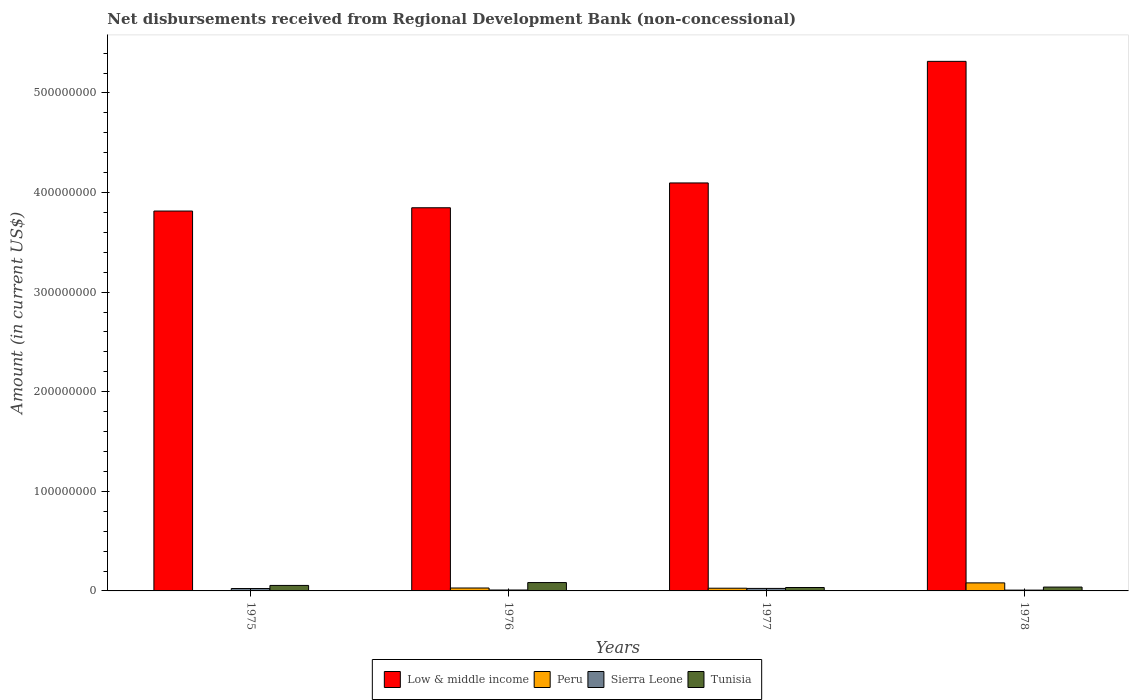How many different coloured bars are there?
Provide a succinct answer. 4. How many groups of bars are there?
Provide a succinct answer. 4. How many bars are there on the 2nd tick from the left?
Provide a short and direct response. 4. What is the label of the 1st group of bars from the left?
Provide a short and direct response. 1975. What is the amount of disbursements received from Regional Development Bank in Tunisia in 1975?
Your answer should be compact. 5.51e+06. Across all years, what is the maximum amount of disbursements received from Regional Development Bank in Peru?
Your response must be concise. 8.07e+06. Across all years, what is the minimum amount of disbursements received from Regional Development Bank in Low & middle income?
Your answer should be compact. 3.81e+08. In which year was the amount of disbursements received from Regional Development Bank in Peru maximum?
Ensure brevity in your answer.  1978. What is the total amount of disbursements received from Regional Development Bank in Low & middle income in the graph?
Keep it short and to the point. 1.71e+09. What is the difference between the amount of disbursements received from Regional Development Bank in Peru in 1976 and that in 1977?
Your answer should be very brief. 2.03e+05. What is the difference between the amount of disbursements received from Regional Development Bank in Low & middle income in 1977 and the amount of disbursements received from Regional Development Bank in Sierra Leone in 1978?
Offer a very short reply. 4.09e+08. What is the average amount of disbursements received from Regional Development Bank in Low & middle income per year?
Offer a very short reply. 4.27e+08. In the year 1976, what is the difference between the amount of disbursements received from Regional Development Bank in Sierra Leone and amount of disbursements received from Regional Development Bank in Peru?
Give a very brief answer. -2.01e+06. What is the ratio of the amount of disbursements received from Regional Development Bank in Sierra Leone in 1975 to that in 1976?
Offer a terse response. 2.64. Is the amount of disbursements received from Regional Development Bank in Low & middle income in 1977 less than that in 1978?
Ensure brevity in your answer.  Yes. What is the difference between the highest and the second highest amount of disbursements received from Regional Development Bank in Tunisia?
Keep it short and to the point. 2.87e+06. What is the difference between the highest and the lowest amount of disbursements received from Regional Development Bank in Tunisia?
Your answer should be very brief. 4.94e+06. Is the sum of the amount of disbursements received from Regional Development Bank in Low & middle income in 1976 and 1978 greater than the maximum amount of disbursements received from Regional Development Bank in Sierra Leone across all years?
Keep it short and to the point. Yes. How many years are there in the graph?
Your answer should be compact. 4. How many legend labels are there?
Make the answer very short. 4. How are the legend labels stacked?
Provide a succinct answer. Horizontal. What is the title of the graph?
Provide a short and direct response. Net disbursements received from Regional Development Bank (non-concessional). Does "India" appear as one of the legend labels in the graph?
Offer a terse response. No. What is the label or title of the Y-axis?
Give a very brief answer. Amount (in current US$). What is the Amount (in current US$) in Low & middle income in 1975?
Provide a succinct answer. 3.81e+08. What is the Amount (in current US$) of Peru in 1975?
Offer a terse response. 0. What is the Amount (in current US$) in Sierra Leone in 1975?
Ensure brevity in your answer.  2.41e+06. What is the Amount (in current US$) of Tunisia in 1975?
Provide a succinct answer. 5.51e+06. What is the Amount (in current US$) in Low & middle income in 1976?
Ensure brevity in your answer.  3.85e+08. What is the Amount (in current US$) of Peru in 1976?
Your response must be concise. 2.93e+06. What is the Amount (in current US$) in Sierra Leone in 1976?
Give a very brief answer. 9.14e+05. What is the Amount (in current US$) in Tunisia in 1976?
Provide a short and direct response. 8.38e+06. What is the Amount (in current US$) in Low & middle income in 1977?
Give a very brief answer. 4.10e+08. What is the Amount (in current US$) of Peru in 1977?
Your response must be concise. 2.72e+06. What is the Amount (in current US$) of Sierra Leone in 1977?
Your response must be concise. 2.51e+06. What is the Amount (in current US$) in Tunisia in 1977?
Provide a short and direct response. 3.44e+06. What is the Amount (in current US$) of Low & middle income in 1978?
Provide a succinct answer. 5.32e+08. What is the Amount (in current US$) in Peru in 1978?
Your answer should be very brief. 8.07e+06. What is the Amount (in current US$) of Sierra Leone in 1978?
Keep it short and to the point. 8.01e+05. What is the Amount (in current US$) in Tunisia in 1978?
Your answer should be very brief. 3.87e+06. Across all years, what is the maximum Amount (in current US$) of Low & middle income?
Make the answer very short. 5.32e+08. Across all years, what is the maximum Amount (in current US$) in Peru?
Offer a very short reply. 8.07e+06. Across all years, what is the maximum Amount (in current US$) in Sierra Leone?
Offer a terse response. 2.51e+06. Across all years, what is the maximum Amount (in current US$) in Tunisia?
Offer a very short reply. 8.38e+06. Across all years, what is the minimum Amount (in current US$) in Low & middle income?
Provide a succinct answer. 3.81e+08. Across all years, what is the minimum Amount (in current US$) in Sierra Leone?
Keep it short and to the point. 8.01e+05. Across all years, what is the minimum Amount (in current US$) in Tunisia?
Offer a very short reply. 3.44e+06. What is the total Amount (in current US$) of Low & middle income in the graph?
Your answer should be very brief. 1.71e+09. What is the total Amount (in current US$) of Peru in the graph?
Keep it short and to the point. 1.37e+07. What is the total Amount (in current US$) of Sierra Leone in the graph?
Your answer should be compact. 6.64e+06. What is the total Amount (in current US$) in Tunisia in the graph?
Keep it short and to the point. 2.12e+07. What is the difference between the Amount (in current US$) in Low & middle income in 1975 and that in 1976?
Offer a terse response. -3.29e+06. What is the difference between the Amount (in current US$) of Sierra Leone in 1975 and that in 1976?
Ensure brevity in your answer.  1.50e+06. What is the difference between the Amount (in current US$) in Tunisia in 1975 and that in 1976?
Offer a terse response. -2.87e+06. What is the difference between the Amount (in current US$) of Low & middle income in 1975 and that in 1977?
Give a very brief answer. -2.82e+07. What is the difference between the Amount (in current US$) of Sierra Leone in 1975 and that in 1977?
Provide a short and direct response. -9.70e+04. What is the difference between the Amount (in current US$) of Tunisia in 1975 and that in 1977?
Provide a short and direct response. 2.07e+06. What is the difference between the Amount (in current US$) of Low & middle income in 1975 and that in 1978?
Provide a short and direct response. -1.50e+08. What is the difference between the Amount (in current US$) in Sierra Leone in 1975 and that in 1978?
Keep it short and to the point. 1.61e+06. What is the difference between the Amount (in current US$) of Tunisia in 1975 and that in 1978?
Your response must be concise. 1.64e+06. What is the difference between the Amount (in current US$) of Low & middle income in 1976 and that in 1977?
Keep it short and to the point. -2.49e+07. What is the difference between the Amount (in current US$) of Peru in 1976 and that in 1977?
Your response must be concise. 2.03e+05. What is the difference between the Amount (in current US$) in Sierra Leone in 1976 and that in 1977?
Your response must be concise. -1.60e+06. What is the difference between the Amount (in current US$) of Tunisia in 1976 and that in 1977?
Keep it short and to the point. 4.94e+06. What is the difference between the Amount (in current US$) of Low & middle income in 1976 and that in 1978?
Provide a succinct answer. -1.47e+08. What is the difference between the Amount (in current US$) in Peru in 1976 and that in 1978?
Ensure brevity in your answer.  -5.14e+06. What is the difference between the Amount (in current US$) in Sierra Leone in 1976 and that in 1978?
Provide a succinct answer. 1.13e+05. What is the difference between the Amount (in current US$) of Tunisia in 1976 and that in 1978?
Provide a short and direct response. 4.51e+06. What is the difference between the Amount (in current US$) of Low & middle income in 1977 and that in 1978?
Keep it short and to the point. -1.22e+08. What is the difference between the Amount (in current US$) of Peru in 1977 and that in 1978?
Make the answer very short. -5.35e+06. What is the difference between the Amount (in current US$) in Sierra Leone in 1977 and that in 1978?
Give a very brief answer. 1.71e+06. What is the difference between the Amount (in current US$) in Tunisia in 1977 and that in 1978?
Offer a terse response. -4.36e+05. What is the difference between the Amount (in current US$) of Low & middle income in 1975 and the Amount (in current US$) of Peru in 1976?
Your answer should be very brief. 3.78e+08. What is the difference between the Amount (in current US$) in Low & middle income in 1975 and the Amount (in current US$) in Sierra Leone in 1976?
Ensure brevity in your answer.  3.81e+08. What is the difference between the Amount (in current US$) in Low & middle income in 1975 and the Amount (in current US$) in Tunisia in 1976?
Offer a terse response. 3.73e+08. What is the difference between the Amount (in current US$) of Sierra Leone in 1975 and the Amount (in current US$) of Tunisia in 1976?
Offer a very short reply. -5.97e+06. What is the difference between the Amount (in current US$) of Low & middle income in 1975 and the Amount (in current US$) of Peru in 1977?
Make the answer very short. 3.79e+08. What is the difference between the Amount (in current US$) in Low & middle income in 1975 and the Amount (in current US$) in Sierra Leone in 1977?
Provide a succinct answer. 3.79e+08. What is the difference between the Amount (in current US$) of Low & middle income in 1975 and the Amount (in current US$) of Tunisia in 1977?
Ensure brevity in your answer.  3.78e+08. What is the difference between the Amount (in current US$) of Sierra Leone in 1975 and the Amount (in current US$) of Tunisia in 1977?
Provide a succinct answer. -1.02e+06. What is the difference between the Amount (in current US$) in Low & middle income in 1975 and the Amount (in current US$) in Peru in 1978?
Offer a very short reply. 3.73e+08. What is the difference between the Amount (in current US$) in Low & middle income in 1975 and the Amount (in current US$) in Sierra Leone in 1978?
Your answer should be very brief. 3.81e+08. What is the difference between the Amount (in current US$) of Low & middle income in 1975 and the Amount (in current US$) of Tunisia in 1978?
Provide a succinct answer. 3.78e+08. What is the difference between the Amount (in current US$) in Sierra Leone in 1975 and the Amount (in current US$) in Tunisia in 1978?
Provide a short and direct response. -1.46e+06. What is the difference between the Amount (in current US$) in Low & middle income in 1976 and the Amount (in current US$) in Peru in 1977?
Make the answer very short. 3.82e+08. What is the difference between the Amount (in current US$) of Low & middle income in 1976 and the Amount (in current US$) of Sierra Leone in 1977?
Offer a very short reply. 3.82e+08. What is the difference between the Amount (in current US$) of Low & middle income in 1976 and the Amount (in current US$) of Tunisia in 1977?
Your answer should be very brief. 3.81e+08. What is the difference between the Amount (in current US$) of Peru in 1976 and the Amount (in current US$) of Sierra Leone in 1977?
Keep it short and to the point. 4.18e+05. What is the difference between the Amount (in current US$) of Peru in 1976 and the Amount (in current US$) of Tunisia in 1977?
Your response must be concise. -5.07e+05. What is the difference between the Amount (in current US$) in Sierra Leone in 1976 and the Amount (in current US$) in Tunisia in 1977?
Keep it short and to the point. -2.52e+06. What is the difference between the Amount (in current US$) of Low & middle income in 1976 and the Amount (in current US$) of Peru in 1978?
Offer a very short reply. 3.77e+08. What is the difference between the Amount (in current US$) of Low & middle income in 1976 and the Amount (in current US$) of Sierra Leone in 1978?
Ensure brevity in your answer.  3.84e+08. What is the difference between the Amount (in current US$) of Low & middle income in 1976 and the Amount (in current US$) of Tunisia in 1978?
Provide a succinct answer. 3.81e+08. What is the difference between the Amount (in current US$) of Peru in 1976 and the Amount (in current US$) of Sierra Leone in 1978?
Give a very brief answer. 2.13e+06. What is the difference between the Amount (in current US$) of Peru in 1976 and the Amount (in current US$) of Tunisia in 1978?
Ensure brevity in your answer.  -9.43e+05. What is the difference between the Amount (in current US$) of Sierra Leone in 1976 and the Amount (in current US$) of Tunisia in 1978?
Your answer should be compact. -2.96e+06. What is the difference between the Amount (in current US$) in Low & middle income in 1977 and the Amount (in current US$) in Peru in 1978?
Provide a short and direct response. 4.02e+08. What is the difference between the Amount (in current US$) in Low & middle income in 1977 and the Amount (in current US$) in Sierra Leone in 1978?
Provide a short and direct response. 4.09e+08. What is the difference between the Amount (in current US$) of Low & middle income in 1977 and the Amount (in current US$) of Tunisia in 1978?
Keep it short and to the point. 4.06e+08. What is the difference between the Amount (in current US$) of Peru in 1977 and the Amount (in current US$) of Sierra Leone in 1978?
Provide a succinct answer. 1.92e+06. What is the difference between the Amount (in current US$) in Peru in 1977 and the Amount (in current US$) in Tunisia in 1978?
Your response must be concise. -1.15e+06. What is the difference between the Amount (in current US$) of Sierra Leone in 1977 and the Amount (in current US$) of Tunisia in 1978?
Offer a terse response. -1.36e+06. What is the average Amount (in current US$) in Low & middle income per year?
Offer a very short reply. 4.27e+08. What is the average Amount (in current US$) of Peru per year?
Make the answer very short. 3.43e+06. What is the average Amount (in current US$) in Sierra Leone per year?
Your response must be concise. 1.66e+06. What is the average Amount (in current US$) of Tunisia per year?
Offer a very short reply. 5.30e+06. In the year 1975, what is the difference between the Amount (in current US$) of Low & middle income and Amount (in current US$) of Sierra Leone?
Make the answer very short. 3.79e+08. In the year 1975, what is the difference between the Amount (in current US$) of Low & middle income and Amount (in current US$) of Tunisia?
Your response must be concise. 3.76e+08. In the year 1975, what is the difference between the Amount (in current US$) of Sierra Leone and Amount (in current US$) of Tunisia?
Give a very brief answer. -3.09e+06. In the year 1976, what is the difference between the Amount (in current US$) of Low & middle income and Amount (in current US$) of Peru?
Your answer should be very brief. 3.82e+08. In the year 1976, what is the difference between the Amount (in current US$) of Low & middle income and Amount (in current US$) of Sierra Leone?
Offer a very short reply. 3.84e+08. In the year 1976, what is the difference between the Amount (in current US$) of Low & middle income and Amount (in current US$) of Tunisia?
Your response must be concise. 3.76e+08. In the year 1976, what is the difference between the Amount (in current US$) in Peru and Amount (in current US$) in Sierra Leone?
Make the answer very short. 2.01e+06. In the year 1976, what is the difference between the Amount (in current US$) of Peru and Amount (in current US$) of Tunisia?
Your answer should be compact. -5.45e+06. In the year 1976, what is the difference between the Amount (in current US$) in Sierra Leone and Amount (in current US$) in Tunisia?
Provide a succinct answer. -7.46e+06. In the year 1977, what is the difference between the Amount (in current US$) of Low & middle income and Amount (in current US$) of Peru?
Your answer should be very brief. 4.07e+08. In the year 1977, what is the difference between the Amount (in current US$) in Low & middle income and Amount (in current US$) in Sierra Leone?
Provide a succinct answer. 4.07e+08. In the year 1977, what is the difference between the Amount (in current US$) in Low & middle income and Amount (in current US$) in Tunisia?
Offer a terse response. 4.06e+08. In the year 1977, what is the difference between the Amount (in current US$) in Peru and Amount (in current US$) in Sierra Leone?
Your response must be concise. 2.15e+05. In the year 1977, what is the difference between the Amount (in current US$) of Peru and Amount (in current US$) of Tunisia?
Offer a very short reply. -7.10e+05. In the year 1977, what is the difference between the Amount (in current US$) in Sierra Leone and Amount (in current US$) in Tunisia?
Make the answer very short. -9.25e+05. In the year 1978, what is the difference between the Amount (in current US$) of Low & middle income and Amount (in current US$) of Peru?
Your answer should be compact. 5.24e+08. In the year 1978, what is the difference between the Amount (in current US$) in Low & middle income and Amount (in current US$) in Sierra Leone?
Keep it short and to the point. 5.31e+08. In the year 1978, what is the difference between the Amount (in current US$) in Low & middle income and Amount (in current US$) in Tunisia?
Offer a very short reply. 5.28e+08. In the year 1978, what is the difference between the Amount (in current US$) in Peru and Amount (in current US$) in Sierra Leone?
Your response must be concise. 7.27e+06. In the year 1978, what is the difference between the Amount (in current US$) of Peru and Amount (in current US$) of Tunisia?
Your answer should be very brief. 4.20e+06. In the year 1978, what is the difference between the Amount (in current US$) of Sierra Leone and Amount (in current US$) of Tunisia?
Give a very brief answer. -3.07e+06. What is the ratio of the Amount (in current US$) in Sierra Leone in 1975 to that in 1976?
Give a very brief answer. 2.64. What is the ratio of the Amount (in current US$) of Tunisia in 1975 to that in 1976?
Provide a short and direct response. 0.66. What is the ratio of the Amount (in current US$) in Low & middle income in 1975 to that in 1977?
Your answer should be very brief. 0.93. What is the ratio of the Amount (in current US$) of Sierra Leone in 1975 to that in 1977?
Your response must be concise. 0.96. What is the ratio of the Amount (in current US$) of Tunisia in 1975 to that in 1977?
Your response must be concise. 1.6. What is the ratio of the Amount (in current US$) of Low & middle income in 1975 to that in 1978?
Give a very brief answer. 0.72. What is the ratio of the Amount (in current US$) of Sierra Leone in 1975 to that in 1978?
Offer a terse response. 3.01. What is the ratio of the Amount (in current US$) of Tunisia in 1975 to that in 1978?
Make the answer very short. 1.42. What is the ratio of the Amount (in current US$) in Low & middle income in 1976 to that in 1977?
Make the answer very short. 0.94. What is the ratio of the Amount (in current US$) in Peru in 1976 to that in 1977?
Keep it short and to the point. 1.07. What is the ratio of the Amount (in current US$) in Sierra Leone in 1976 to that in 1977?
Give a very brief answer. 0.36. What is the ratio of the Amount (in current US$) in Tunisia in 1976 to that in 1977?
Your answer should be very brief. 2.44. What is the ratio of the Amount (in current US$) in Low & middle income in 1976 to that in 1978?
Ensure brevity in your answer.  0.72. What is the ratio of the Amount (in current US$) of Peru in 1976 to that in 1978?
Keep it short and to the point. 0.36. What is the ratio of the Amount (in current US$) in Sierra Leone in 1976 to that in 1978?
Ensure brevity in your answer.  1.14. What is the ratio of the Amount (in current US$) of Tunisia in 1976 to that in 1978?
Ensure brevity in your answer.  2.16. What is the ratio of the Amount (in current US$) of Low & middle income in 1977 to that in 1978?
Offer a very short reply. 0.77. What is the ratio of the Amount (in current US$) in Peru in 1977 to that in 1978?
Provide a short and direct response. 0.34. What is the ratio of the Amount (in current US$) of Sierra Leone in 1977 to that in 1978?
Provide a short and direct response. 3.13. What is the ratio of the Amount (in current US$) in Tunisia in 1977 to that in 1978?
Make the answer very short. 0.89. What is the difference between the highest and the second highest Amount (in current US$) in Low & middle income?
Offer a very short reply. 1.22e+08. What is the difference between the highest and the second highest Amount (in current US$) in Peru?
Offer a terse response. 5.14e+06. What is the difference between the highest and the second highest Amount (in current US$) in Sierra Leone?
Ensure brevity in your answer.  9.70e+04. What is the difference between the highest and the second highest Amount (in current US$) in Tunisia?
Offer a terse response. 2.87e+06. What is the difference between the highest and the lowest Amount (in current US$) of Low & middle income?
Provide a succinct answer. 1.50e+08. What is the difference between the highest and the lowest Amount (in current US$) of Peru?
Provide a succinct answer. 8.07e+06. What is the difference between the highest and the lowest Amount (in current US$) of Sierra Leone?
Your answer should be very brief. 1.71e+06. What is the difference between the highest and the lowest Amount (in current US$) in Tunisia?
Provide a short and direct response. 4.94e+06. 